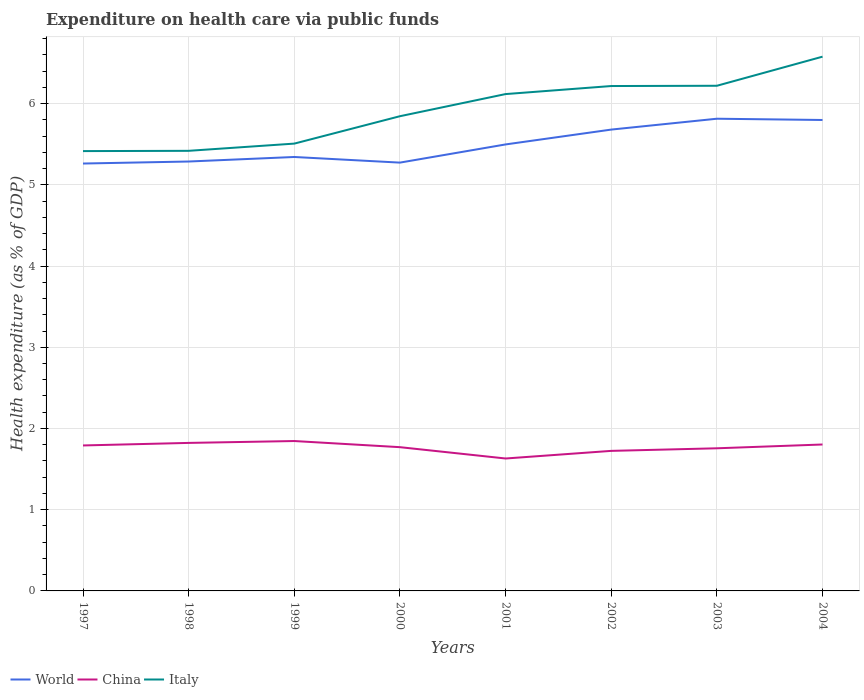How many different coloured lines are there?
Offer a very short reply. 3. Does the line corresponding to China intersect with the line corresponding to Italy?
Keep it short and to the point. No. Across all years, what is the maximum expenditure made on health care in China?
Your answer should be very brief. 1.63. In which year was the expenditure made on health care in China maximum?
Your answer should be very brief. 2001. What is the total expenditure made on health care in Italy in the graph?
Your answer should be very brief. -0.71. What is the difference between the highest and the second highest expenditure made on health care in Italy?
Provide a short and direct response. 1.16. How many lines are there?
Your response must be concise. 3. How many years are there in the graph?
Offer a very short reply. 8. What is the difference between two consecutive major ticks on the Y-axis?
Provide a short and direct response. 1. Are the values on the major ticks of Y-axis written in scientific E-notation?
Keep it short and to the point. No. Does the graph contain grids?
Your answer should be compact. Yes. How many legend labels are there?
Provide a succinct answer. 3. What is the title of the graph?
Offer a very short reply. Expenditure on health care via public funds. Does "Kiribati" appear as one of the legend labels in the graph?
Keep it short and to the point. No. What is the label or title of the Y-axis?
Make the answer very short. Health expenditure (as % of GDP). What is the Health expenditure (as % of GDP) of World in 1997?
Offer a terse response. 5.26. What is the Health expenditure (as % of GDP) of China in 1997?
Provide a short and direct response. 1.79. What is the Health expenditure (as % of GDP) of Italy in 1997?
Your answer should be compact. 5.42. What is the Health expenditure (as % of GDP) in World in 1998?
Offer a very short reply. 5.29. What is the Health expenditure (as % of GDP) of China in 1998?
Provide a short and direct response. 1.82. What is the Health expenditure (as % of GDP) of Italy in 1998?
Give a very brief answer. 5.42. What is the Health expenditure (as % of GDP) in World in 1999?
Give a very brief answer. 5.34. What is the Health expenditure (as % of GDP) in China in 1999?
Offer a terse response. 1.85. What is the Health expenditure (as % of GDP) in Italy in 1999?
Give a very brief answer. 5.51. What is the Health expenditure (as % of GDP) of World in 2000?
Your answer should be compact. 5.27. What is the Health expenditure (as % of GDP) in China in 2000?
Give a very brief answer. 1.77. What is the Health expenditure (as % of GDP) of Italy in 2000?
Provide a short and direct response. 5.84. What is the Health expenditure (as % of GDP) in World in 2001?
Make the answer very short. 5.5. What is the Health expenditure (as % of GDP) of China in 2001?
Offer a very short reply. 1.63. What is the Health expenditure (as % of GDP) in Italy in 2001?
Your answer should be compact. 6.12. What is the Health expenditure (as % of GDP) in World in 2002?
Your answer should be very brief. 5.68. What is the Health expenditure (as % of GDP) in China in 2002?
Offer a very short reply. 1.72. What is the Health expenditure (as % of GDP) in Italy in 2002?
Offer a terse response. 6.22. What is the Health expenditure (as % of GDP) of World in 2003?
Offer a terse response. 5.81. What is the Health expenditure (as % of GDP) in China in 2003?
Provide a short and direct response. 1.76. What is the Health expenditure (as % of GDP) in Italy in 2003?
Offer a terse response. 6.22. What is the Health expenditure (as % of GDP) of World in 2004?
Make the answer very short. 5.8. What is the Health expenditure (as % of GDP) of China in 2004?
Ensure brevity in your answer.  1.8. What is the Health expenditure (as % of GDP) in Italy in 2004?
Offer a very short reply. 6.58. Across all years, what is the maximum Health expenditure (as % of GDP) of World?
Your answer should be compact. 5.81. Across all years, what is the maximum Health expenditure (as % of GDP) of China?
Your answer should be very brief. 1.85. Across all years, what is the maximum Health expenditure (as % of GDP) of Italy?
Your response must be concise. 6.58. Across all years, what is the minimum Health expenditure (as % of GDP) in World?
Give a very brief answer. 5.26. Across all years, what is the minimum Health expenditure (as % of GDP) in China?
Make the answer very short. 1.63. Across all years, what is the minimum Health expenditure (as % of GDP) of Italy?
Provide a short and direct response. 5.42. What is the total Health expenditure (as % of GDP) of World in the graph?
Provide a short and direct response. 43.95. What is the total Health expenditure (as % of GDP) in China in the graph?
Provide a succinct answer. 14.14. What is the total Health expenditure (as % of GDP) in Italy in the graph?
Your response must be concise. 47.32. What is the difference between the Health expenditure (as % of GDP) of World in 1997 and that in 1998?
Offer a very short reply. -0.02. What is the difference between the Health expenditure (as % of GDP) in China in 1997 and that in 1998?
Give a very brief answer. -0.03. What is the difference between the Health expenditure (as % of GDP) of Italy in 1997 and that in 1998?
Keep it short and to the point. -0. What is the difference between the Health expenditure (as % of GDP) in World in 1997 and that in 1999?
Your response must be concise. -0.08. What is the difference between the Health expenditure (as % of GDP) in China in 1997 and that in 1999?
Offer a very short reply. -0.05. What is the difference between the Health expenditure (as % of GDP) in Italy in 1997 and that in 1999?
Your response must be concise. -0.09. What is the difference between the Health expenditure (as % of GDP) of World in 1997 and that in 2000?
Provide a succinct answer. -0.01. What is the difference between the Health expenditure (as % of GDP) in China in 1997 and that in 2000?
Ensure brevity in your answer.  0.02. What is the difference between the Health expenditure (as % of GDP) of Italy in 1997 and that in 2000?
Make the answer very short. -0.43. What is the difference between the Health expenditure (as % of GDP) in World in 1997 and that in 2001?
Offer a very short reply. -0.24. What is the difference between the Health expenditure (as % of GDP) of China in 1997 and that in 2001?
Make the answer very short. 0.16. What is the difference between the Health expenditure (as % of GDP) in Italy in 1997 and that in 2001?
Ensure brevity in your answer.  -0.7. What is the difference between the Health expenditure (as % of GDP) of World in 1997 and that in 2002?
Your response must be concise. -0.42. What is the difference between the Health expenditure (as % of GDP) of China in 1997 and that in 2002?
Provide a succinct answer. 0.07. What is the difference between the Health expenditure (as % of GDP) in Italy in 1997 and that in 2002?
Make the answer very short. -0.8. What is the difference between the Health expenditure (as % of GDP) in World in 1997 and that in 2003?
Provide a short and direct response. -0.55. What is the difference between the Health expenditure (as % of GDP) of China in 1997 and that in 2003?
Your answer should be compact. 0.03. What is the difference between the Health expenditure (as % of GDP) in Italy in 1997 and that in 2003?
Provide a short and direct response. -0.8. What is the difference between the Health expenditure (as % of GDP) in World in 1997 and that in 2004?
Your response must be concise. -0.54. What is the difference between the Health expenditure (as % of GDP) in China in 1997 and that in 2004?
Make the answer very short. -0.01. What is the difference between the Health expenditure (as % of GDP) in Italy in 1997 and that in 2004?
Keep it short and to the point. -1.16. What is the difference between the Health expenditure (as % of GDP) of World in 1998 and that in 1999?
Your response must be concise. -0.06. What is the difference between the Health expenditure (as % of GDP) of China in 1998 and that in 1999?
Offer a terse response. -0.02. What is the difference between the Health expenditure (as % of GDP) of Italy in 1998 and that in 1999?
Your response must be concise. -0.09. What is the difference between the Health expenditure (as % of GDP) in World in 1998 and that in 2000?
Keep it short and to the point. 0.01. What is the difference between the Health expenditure (as % of GDP) in China in 1998 and that in 2000?
Keep it short and to the point. 0.05. What is the difference between the Health expenditure (as % of GDP) of Italy in 1998 and that in 2000?
Provide a succinct answer. -0.43. What is the difference between the Health expenditure (as % of GDP) of World in 1998 and that in 2001?
Your answer should be very brief. -0.21. What is the difference between the Health expenditure (as % of GDP) in China in 1998 and that in 2001?
Keep it short and to the point. 0.19. What is the difference between the Health expenditure (as % of GDP) of Italy in 1998 and that in 2001?
Provide a short and direct response. -0.7. What is the difference between the Health expenditure (as % of GDP) of World in 1998 and that in 2002?
Provide a succinct answer. -0.39. What is the difference between the Health expenditure (as % of GDP) in China in 1998 and that in 2002?
Offer a very short reply. 0.1. What is the difference between the Health expenditure (as % of GDP) of Italy in 1998 and that in 2002?
Provide a short and direct response. -0.8. What is the difference between the Health expenditure (as % of GDP) in World in 1998 and that in 2003?
Give a very brief answer. -0.53. What is the difference between the Health expenditure (as % of GDP) in China in 1998 and that in 2003?
Provide a succinct answer. 0.07. What is the difference between the Health expenditure (as % of GDP) of Italy in 1998 and that in 2003?
Offer a very short reply. -0.8. What is the difference between the Health expenditure (as % of GDP) in World in 1998 and that in 2004?
Your answer should be very brief. -0.51. What is the difference between the Health expenditure (as % of GDP) of China in 1998 and that in 2004?
Make the answer very short. 0.02. What is the difference between the Health expenditure (as % of GDP) in Italy in 1998 and that in 2004?
Provide a short and direct response. -1.16. What is the difference between the Health expenditure (as % of GDP) in World in 1999 and that in 2000?
Your answer should be compact. 0.07. What is the difference between the Health expenditure (as % of GDP) of China in 1999 and that in 2000?
Make the answer very short. 0.08. What is the difference between the Health expenditure (as % of GDP) of Italy in 1999 and that in 2000?
Ensure brevity in your answer.  -0.34. What is the difference between the Health expenditure (as % of GDP) in World in 1999 and that in 2001?
Make the answer very short. -0.15. What is the difference between the Health expenditure (as % of GDP) of China in 1999 and that in 2001?
Keep it short and to the point. 0.21. What is the difference between the Health expenditure (as % of GDP) of Italy in 1999 and that in 2001?
Your response must be concise. -0.61. What is the difference between the Health expenditure (as % of GDP) in World in 1999 and that in 2002?
Your answer should be very brief. -0.34. What is the difference between the Health expenditure (as % of GDP) of China in 1999 and that in 2002?
Your answer should be compact. 0.12. What is the difference between the Health expenditure (as % of GDP) of Italy in 1999 and that in 2002?
Provide a succinct answer. -0.71. What is the difference between the Health expenditure (as % of GDP) in World in 1999 and that in 2003?
Your answer should be compact. -0.47. What is the difference between the Health expenditure (as % of GDP) in China in 1999 and that in 2003?
Your answer should be very brief. 0.09. What is the difference between the Health expenditure (as % of GDP) of Italy in 1999 and that in 2003?
Your answer should be very brief. -0.71. What is the difference between the Health expenditure (as % of GDP) in World in 1999 and that in 2004?
Provide a succinct answer. -0.46. What is the difference between the Health expenditure (as % of GDP) in China in 1999 and that in 2004?
Offer a very short reply. 0.04. What is the difference between the Health expenditure (as % of GDP) of Italy in 1999 and that in 2004?
Keep it short and to the point. -1.07. What is the difference between the Health expenditure (as % of GDP) of World in 2000 and that in 2001?
Keep it short and to the point. -0.22. What is the difference between the Health expenditure (as % of GDP) of China in 2000 and that in 2001?
Make the answer very short. 0.14. What is the difference between the Health expenditure (as % of GDP) of Italy in 2000 and that in 2001?
Ensure brevity in your answer.  -0.27. What is the difference between the Health expenditure (as % of GDP) in World in 2000 and that in 2002?
Your answer should be very brief. -0.41. What is the difference between the Health expenditure (as % of GDP) of China in 2000 and that in 2002?
Your answer should be very brief. 0.05. What is the difference between the Health expenditure (as % of GDP) in Italy in 2000 and that in 2002?
Provide a succinct answer. -0.37. What is the difference between the Health expenditure (as % of GDP) in World in 2000 and that in 2003?
Provide a short and direct response. -0.54. What is the difference between the Health expenditure (as % of GDP) of China in 2000 and that in 2003?
Offer a terse response. 0.01. What is the difference between the Health expenditure (as % of GDP) of Italy in 2000 and that in 2003?
Give a very brief answer. -0.37. What is the difference between the Health expenditure (as % of GDP) in World in 2000 and that in 2004?
Ensure brevity in your answer.  -0.53. What is the difference between the Health expenditure (as % of GDP) of China in 2000 and that in 2004?
Offer a terse response. -0.03. What is the difference between the Health expenditure (as % of GDP) in Italy in 2000 and that in 2004?
Make the answer very short. -0.73. What is the difference between the Health expenditure (as % of GDP) of World in 2001 and that in 2002?
Your answer should be compact. -0.18. What is the difference between the Health expenditure (as % of GDP) in China in 2001 and that in 2002?
Give a very brief answer. -0.09. What is the difference between the Health expenditure (as % of GDP) of Italy in 2001 and that in 2002?
Keep it short and to the point. -0.1. What is the difference between the Health expenditure (as % of GDP) of World in 2001 and that in 2003?
Provide a succinct answer. -0.32. What is the difference between the Health expenditure (as % of GDP) of China in 2001 and that in 2003?
Your response must be concise. -0.13. What is the difference between the Health expenditure (as % of GDP) of Italy in 2001 and that in 2003?
Your answer should be very brief. -0.1. What is the difference between the Health expenditure (as % of GDP) of World in 2001 and that in 2004?
Give a very brief answer. -0.3. What is the difference between the Health expenditure (as % of GDP) in China in 2001 and that in 2004?
Offer a terse response. -0.17. What is the difference between the Health expenditure (as % of GDP) in Italy in 2001 and that in 2004?
Your response must be concise. -0.46. What is the difference between the Health expenditure (as % of GDP) in World in 2002 and that in 2003?
Give a very brief answer. -0.13. What is the difference between the Health expenditure (as % of GDP) in China in 2002 and that in 2003?
Keep it short and to the point. -0.03. What is the difference between the Health expenditure (as % of GDP) in Italy in 2002 and that in 2003?
Your answer should be compact. -0. What is the difference between the Health expenditure (as % of GDP) in World in 2002 and that in 2004?
Provide a short and direct response. -0.12. What is the difference between the Health expenditure (as % of GDP) of China in 2002 and that in 2004?
Your answer should be compact. -0.08. What is the difference between the Health expenditure (as % of GDP) of Italy in 2002 and that in 2004?
Offer a terse response. -0.36. What is the difference between the Health expenditure (as % of GDP) in World in 2003 and that in 2004?
Give a very brief answer. 0.02. What is the difference between the Health expenditure (as % of GDP) in China in 2003 and that in 2004?
Offer a very short reply. -0.05. What is the difference between the Health expenditure (as % of GDP) of Italy in 2003 and that in 2004?
Give a very brief answer. -0.36. What is the difference between the Health expenditure (as % of GDP) in World in 1997 and the Health expenditure (as % of GDP) in China in 1998?
Provide a short and direct response. 3.44. What is the difference between the Health expenditure (as % of GDP) of World in 1997 and the Health expenditure (as % of GDP) of Italy in 1998?
Give a very brief answer. -0.16. What is the difference between the Health expenditure (as % of GDP) of China in 1997 and the Health expenditure (as % of GDP) of Italy in 1998?
Your response must be concise. -3.63. What is the difference between the Health expenditure (as % of GDP) of World in 1997 and the Health expenditure (as % of GDP) of China in 1999?
Make the answer very short. 3.42. What is the difference between the Health expenditure (as % of GDP) in World in 1997 and the Health expenditure (as % of GDP) in Italy in 1999?
Offer a very short reply. -0.25. What is the difference between the Health expenditure (as % of GDP) of China in 1997 and the Health expenditure (as % of GDP) of Italy in 1999?
Your response must be concise. -3.72. What is the difference between the Health expenditure (as % of GDP) of World in 1997 and the Health expenditure (as % of GDP) of China in 2000?
Your answer should be very brief. 3.49. What is the difference between the Health expenditure (as % of GDP) in World in 1997 and the Health expenditure (as % of GDP) in Italy in 2000?
Offer a very short reply. -0.58. What is the difference between the Health expenditure (as % of GDP) in China in 1997 and the Health expenditure (as % of GDP) in Italy in 2000?
Offer a very short reply. -4.05. What is the difference between the Health expenditure (as % of GDP) of World in 1997 and the Health expenditure (as % of GDP) of China in 2001?
Provide a short and direct response. 3.63. What is the difference between the Health expenditure (as % of GDP) of World in 1997 and the Health expenditure (as % of GDP) of Italy in 2001?
Ensure brevity in your answer.  -0.86. What is the difference between the Health expenditure (as % of GDP) of China in 1997 and the Health expenditure (as % of GDP) of Italy in 2001?
Your answer should be compact. -4.33. What is the difference between the Health expenditure (as % of GDP) in World in 1997 and the Health expenditure (as % of GDP) in China in 2002?
Offer a terse response. 3.54. What is the difference between the Health expenditure (as % of GDP) in World in 1997 and the Health expenditure (as % of GDP) in Italy in 2002?
Provide a succinct answer. -0.95. What is the difference between the Health expenditure (as % of GDP) of China in 1997 and the Health expenditure (as % of GDP) of Italy in 2002?
Keep it short and to the point. -4.43. What is the difference between the Health expenditure (as % of GDP) in World in 1997 and the Health expenditure (as % of GDP) in China in 2003?
Your response must be concise. 3.51. What is the difference between the Health expenditure (as % of GDP) in World in 1997 and the Health expenditure (as % of GDP) in Italy in 2003?
Offer a very short reply. -0.96. What is the difference between the Health expenditure (as % of GDP) of China in 1997 and the Health expenditure (as % of GDP) of Italy in 2003?
Provide a short and direct response. -4.43. What is the difference between the Health expenditure (as % of GDP) of World in 1997 and the Health expenditure (as % of GDP) of China in 2004?
Offer a very short reply. 3.46. What is the difference between the Health expenditure (as % of GDP) in World in 1997 and the Health expenditure (as % of GDP) in Italy in 2004?
Keep it short and to the point. -1.32. What is the difference between the Health expenditure (as % of GDP) in China in 1997 and the Health expenditure (as % of GDP) in Italy in 2004?
Offer a very short reply. -4.79. What is the difference between the Health expenditure (as % of GDP) of World in 1998 and the Health expenditure (as % of GDP) of China in 1999?
Ensure brevity in your answer.  3.44. What is the difference between the Health expenditure (as % of GDP) in World in 1998 and the Health expenditure (as % of GDP) in Italy in 1999?
Offer a terse response. -0.22. What is the difference between the Health expenditure (as % of GDP) of China in 1998 and the Health expenditure (as % of GDP) of Italy in 1999?
Provide a succinct answer. -3.68. What is the difference between the Health expenditure (as % of GDP) in World in 1998 and the Health expenditure (as % of GDP) in China in 2000?
Your answer should be compact. 3.52. What is the difference between the Health expenditure (as % of GDP) of World in 1998 and the Health expenditure (as % of GDP) of Italy in 2000?
Keep it short and to the point. -0.56. What is the difference between the Health expenditure (as % of GDP) in China in 1998 and the Health expenditure (as % of GDP) in Italy in 2000?
Ensure brevity in your answer.  -4.02. What is the difference between the Health expenditure (as % of GDP) of World in 1998 and the Health expenditure (as % of GDP) of China in 2001?
Make the answer very short. 3.66. What is the difference between the Health expenditure (as % of GDP) in World in 1998 and the Health expenditure (as % of GDP) in Italy in 2001?
Provide a succinct answer. -0.83. What is the difference between the Health expenditure (as % of GDP) of China in 1998 and the Health expenditure (as % of GDP) of Italy in 2001?
Make the answer very short. -4.29. What is the difference between the Health expenditure (as % of GDP) in World in 1998 and the Health expenditure (as % of GDP) in China in 2002?
Offer a terse response. 3.56. What is the difference between the Health expenditure (as % of GDP) in World in 1998 and the Health expenditure (as % of GDP) in Italy in 2002?
Your response must be concise. -0.93. What is the difference between the Health expenditure (as % of GDP) of China in 1998 and the Health expenditure (as % of GDP) of Italy in 2002?
Ensure brevity in your answer.  -4.39. What is the difference between the Health expenditure (as % of GDP) in World in 1998 and the Health expenditure (as % of GDP) in China in 2003?
Offer a very short reply. 3.53. What is the difference between the Health expenditure (as % of GDP) in World in 1998 and the Health expenditure (as % of GDP) in Italy in 2003?
Make the answer very short. -0.93. What is the difference between the Health expenditure (as % of GDP) of China in 1998 and the Health expenditure (as % of GDP) of Italy in 2003?
Keep it short and to the point. -4.4. What is the difference between the Health expenditure (as % of GDP) in World in 1998 and the Health expenditure (as % of GDP) in China in 2004?
Provide a short and direct response. 3.48. What is the difference between the Health expenditure (as % of GDP) of World in 1998 and the Health expenditure (as % of GDP) of Italy in 2004?
Make the answer very short. -1.29. What is the difference between the Health expenditure (as % of GDP) of China in 1998 and the Health expenditure (as % of GDP) of Italy in 2004?
Your answer should be compact. -4.76. What is the difference between the Health expenditure (as % of GDP) in World in 1999 and the Health expenditure (as % of GDP) in China in 2000?
Your answer should be very brief. 3.57. What is the difference between the Health expenditure (as % of GDP) of World in 1999 and the Health expenditure (as % of GDP) of Italy in 2000?
Offer a very short reply. -0.5. What is the difference between the Health expenditure (as % of GDP) of China in 1999 and the Health expenditure (as % of GDP) of Italy in 2000?
Make the answer very short. -4. What is the difference between the Health expenditure (as % of GDP) in World in 1999 and the Health expenditure (as % of GDP) in China in 2001?
Give a very brief answer. 3.71. What is the difference between the Health expenditure (as % of GDP) of World in 1999 and the Health expenditure (as % of GDP) of Italy in 2001?
Provide a succinct answer. -0.77. What is the difference between the Health expenditure (as % of GDP) in China in 1999 and the Health expenditure (as % of GDP) in Italy in 2001?
Make the answer very short. -4.27. What is the difference between the Health expenditure (as % of GDP) of World in 1999 and the Health expenditure (as % of GDP) of China in 2002?
Offer a very short reply. 3.62. What is the difference between the Health expenditure (as % of GDP) of World in 1999 and the Health expenditure (as % of GDP) of Italy in 2002?
Ensure brevity in your answer.  -0.87. What is the difference between the Health expenditure (as % of GDP) of China in 1999 and the Health expenditure (as % of GDP) of Italy in 2002?
Provide a succinct answer. -4.37. What is the difference between the Health expenditure (as % of GDP) in World in 1999 and the Health expenditure (as % of GDP) in China in 2003?
Your answer should be very brief. 3.59. What is the difference between the Health expenditure (as % of GDP) in World in 1999 and the Health expenditure (as % of GDP) in Italy in 2003?
Keep it short and to the point. -0.88. What is the difference between the Health expenditure (as % of GDP) of China in 1999 and the Health expenditure (as % of GDP) of Italy in 2003?
Provide a short and direct response. -4.37. What is the difference between the Health expenditure (as % of GDP) of World in 1999 and the Health expenditure (as % of GDP) of China in 2004?
Provide a short and direct response. 3.54. What is the difference between the Health expenditure (as % of GDP) in World in 1999 and the Health expenditure (as % of GDP) in Italy in 2004?
Provide a succinct answer. -1.24. What is the difference between the Health expenditure (as % of GDP) in China in 1999 and the Health expenditure (as % of GDP) in Italy in 2004?
Make the answer very short. -4.73. What is the difference between the Health expenditure (as % of GDP) of World in 2000 and the Health expenditure (as % of GDP) of China in 2001?
Your response must be concise. 3.64. What is the difference between the Health expenditure (as % of GDP) of World in 2000 and the Health expenditure (as % of GDP) of Italy in 2001?
Offer a terse response. -0.84. What is the difference between the Health expenditure (as % of GDP) of China in 2000 and the Health expenditure (as % of GDP) of Italy in 2001?
Give a very brief answer. -4.35. What is the difference between the Health expenditure (as % of GDP) of World in 2000 and the Health expenditure (as % of GDP) of China in 2002?
Your response must be concise. 3.55. What is the difference between the Health expenditure (as % of GDP) of World in 2000 and the Health expenditure (as % of GDP) of Italy in 2002?
Keep it short and to the point. -0.94. What is the difference between the Health expenditure (as % of GDP) in China in 2000 and the Health expenditure (as % of GDP) in Italy in 2002?
Offer a very short reply. -4.45. What is the difference between the Health expenditure (as % of GDP) in World in 2000 and the Health expenditure (as % of GDP) in China in 2003?
Ensure brevity in your answer.  3.52. What is the difference between the Health expenditure (as % of GDP) of World in 2000 and the Health expenditure (as % of GDP) of Italy in 2003?
Offer a terse response. -0.95. What is the difference between the Health expenditure (as % of GDP) in China in 2000 and the Health expenditure (as % of GDP) in Italy in 2003?
Your answer should be compact. -4.45. What is the difference between the Health expenditure (as % of GDP) of World in 2000 and the Health expenditure (as % of GDP) of China in 2004?
Your answer should be compact. 3.47. What is the difference between the Health expenditure (as % of GDP) in World in 2000 and the Health expenditure (as % of GDP) in Italy in 2004?
Your answer should be compact. -1.3. What is the difference between the Health expenditure (as % of GDP) of China in 2000 and the Health expenditure (as % of GDP) of Italy in 2004?
Your answer should be very brief. -4.81. What is the difference between the Health expenditure (as % of GDP) in World in 2001 and the Health expenditure (as % of GDP) in China in 2002?
Your answer should be very brief. 3.77. What is the difference between the Health expenditure (as % of GDP) in World in 2001 and the Health expenditure (as % of GDP) in Italy in 2002?
Provide a succinct answer. -0.72. What is the difference between the Health expenditure (as % of GDP) in China in 2001 and the Health expenditure (as % of GDP) in Italy in 2002?
Offer a terse response. -4.59. What is the difference between the Health expenditure (as % of GDP) in World in 2001 and the Health expenditure (as % of GDP) in China in 2003?
Keep it short and to the point. 3.74. What is the difference between the Health expenditure (as % of GDP) in World in 2001 and the Health expenditure (as % of GDP) in Italy in 2003?
Provide a short and direct response. -0.72. What is the difference between the Health expenditure (as % of GDP) of China in 2001 and the Health expenditure (as % of GDP) of Italy in 2003?
Your answer should be compact. -4.59. What is the difference between the Health expenditure (as % of GDP) of World in 2001 and the Health expenditure (as % of GDP) of China in 2004?
Provide a short and direct response. 3.69. What is the difference between the Health expenditure (as % of GDP) in World in 2001 and the Health expenditure (as % of GDP) in Italy in 2004?
Make the answer very short. -1.08. What is the difference between the Health expenditure (as % of GDP) of China in 2001 and the Health expenditure (as % of GDP) of Italy in 2004?
Keep it short and to the point. -4.95. What is the difference between the Health expenditure (as % of GDP) in World in 2002 and the Health expenditure (as % of GDP) in China in 2003?
Provide a short and direct response. 3.92. What is the difference between the Health expenditure (as % of GDP) in World in 2002 and the Health expenditure (as % of GDP) in Italy in 2003?
Keep it short and to the point. -0.54. What is the difference between the Health expenditure (as % of GDP) in China in 2002 and the Health expenditure (as % of GDP) in Italy in 2003?
Offer a terse response. -4.5. What is the difference between the Health expenditure (as % of GDP) in World in 2002 and the Health expenditure (as % of GDP) in China in 2004?
Keep it short and to the point. 3.88. What is the difference between the Health expenditure (as % of GDP) of World in 2002 and the Health expenditure (as % of GDP) of Italy in 2004?
Your response must be concise. -0.9. What is the difference between the Health expenditure (as % of GDP) in China in 2002 and the Health expenditure (as % of GDP) in Italy in 2004?
Make the answer very short. -4.85. What is the difference between the Health expenditure (as % of GDP) in World in 2003 and the Health expenditure (as % of GDP) in China in 2004?
Your answer should be very brief. 4.01. What is the difference between the Health expenditure (as % of GDP) in World in 2003 and the Health expenditure (as % of GDP) in Italy in 2004?
Provide a succinct answer. -0.76. What is the difference between the Health expenditure (as % of GDP) of China in 2003 and the Health expenditure (as % of GDP) of Italy in 2004?
Make the answer very short. -4.82. What is the average Health expenditure (as % of GDP) of World per year?
Give a very brief answer. 5.49. What is the average Health expenditure (as % of GDP) in China per year?
Offer a terse response. 1.77. What is the average Health expenditure (as % of GDP) in Italy per year?
Your answer should be compact. 5.91. In the year 1997, what is the difference between the Health expenditure (as % of GDP) of World and Health expenditure (as % of GDP) of China?
Your response must be concise. 3.47. In the year 1997, what is the difference between the Health expenditure (as % of GDP) in World and Health expenditure (as % of GDP) in Italy?
Keep it short and to the point. -0.15. In the year 1997, what is the difference between the Health expenditure (as % of GDP) of China and Health expenditure (as % of GDP) of Italy?
Give a very brief answer. -3.62. In the year 1998, what is the difference between the Health expenditure (as % of GDP) in World and Health expenditure (as % of GDP) in China?
Give a very brief answer. 3.46. In the year 1998, what is the difference between the Health expenditure (as % of GDP) of World and Health expenditure (as % of GDP) of Italy?
Ensure brevity in your answer.  -0.13. In the year 1998, what is the difference between the Health expenditure (as % of GDP) of China and Health expenditure (as % of GDP) of Italy?
Your answer should be very brief. -3.6. In the year 1999, what is the difference between the Health expenditure (as % of GDP) of World and Health expenditure (as % of GDP) of China?
Provide a succinct answer. 3.5. In the year 1999, what is the difference between the Health expenditure (as % of GDP) in World and Health expenditure (as % of GDP) in Italy?
Provide a short and direct response. -0.16. In the year 1999, what is the difference between the Health expenditure (as % of GDP) in China and Health expenditure (as % of GDP) in Italy?
Your answer should be compact. -3.66. In the year 2000, what is the difference between the Health expenditure (as % of GDP) in World and Health expenditure (as % of GDP) in China?
Your answer should be compact. 3.5. In the year 2000, what is the difference between the Health expenditure (as % of GDP) in World and Health expenditure (as % of GDP) in Italy?
Give a very brief answer. -0.57. In the year 2000, what is the difference between the Health expenditure (as % of GDP) of China and Health expenditure (as % of GDP) of Italy?
Your response must be concise. -4.07. In the year 2001, what is the difference between the Health expenditure (as % of GDP) of World and Health expenditure (as % of GDP) of China?
Make the answer very short. 3.87. In the year 2001, what is the difference between the Health expenditure (as % of GDP) of World and Health expenditure (as % of GDP) of Italy?
Keep it short and to the point. -0.62. In the year 2001, what is the difference between the Health expenditure (as % of GDP) in China and Health expenditure (as % of GDP) in Italy?
Offer a terse response. -4.49. In the year 2002, what is the difference between the Health expenditure (as % of GDP) in World and Health expenditure (as % of GDP) in China?
Provide a short and direct response. 3.96. In the year 2002, what is the difference between the Health expenditure (as % of GDP) in World and Health expenditure (as % of GDP) in Italy?
Give a very brief answer. -0.54. In the year 2002, what is the difference between the Health expenditure (as % of GDP) in China and Health expenditure (as % of GDP) in Italy?
Provide a short and direct response. -4.49. In the year 2003, what is the difference between the Health expenditure (as % of GDP) of World and Health expenditure (as % of GDP) of China?
Ensure brevity in your answer.  4.06. In the year 2003, what is the difference between the Health expenditure (as % of GDP) of World and Health expenditure (as % of GDP) of Italy?
Make the answer very short. -0.41. In the year 2003, what is the difference between the Health expenditure (as % of GDP) in China and Health expenditure (as % of GDP) in Italy?
Your response must be concise. -4.46. In the year 2004, what is the difference between the Health expenditure (as % of GDP) in World and Health expenditure (as % of GDP) in China?
Offer a terse response. 4. In the year 2004, what is the difference between the Health expenditure (as % of GDP) in World and Health expenditure (as % of GDP) in Italy?
Give a very brief answer. -0.78. In the year 2004, what is the difference between the Health expenditure (as % of GDP) in China and Health expenditure (as % of GDP) in Italy?
Your answer should be compact. -4.77. What is the ratio of the Health expenditure (as % of GDP) of China in 1997 to that in 1998?
Provide a succinct answer. 0.98. What is the ratio of the Health expenditure (as % of GDP) in World in 1997 to that in 1999?
Ensure brevity in your answer.  0.98. What is the ratio of the Health expenditure (as % of GDP) in China in 1997 to that in 1999?
Offer a very short reply. 0.97. What is the ratio of the Health expenditure (as % of GDP) of Italy in 1997 to that in 1999?
Keep it short and to the point. 0.98. What is the ratio of the Health expenditure (as % of GDP) of China in 1997 to that in 2000?
Your response must be concise. 1.01. What is the ratio of the Health expenditure (as % of GDP) of Italy in 1997 to that in 2000?
Provide a short and direct response. 0.93. What is the ratio of the Health expenditure (as % of GDP) of World in 1997 to that in 2001?
Your answer should be very brief. 0.96. What is the ratio of the Health expenditure (as % of GDP) in China in 1997 to that in 2001?
Provide a succinct answer. 1.1. What is the ratio of the Health expenditure (as % of GDP) of Italy in 1997 to that in 2001?
Keep it short and to the point. 0.89. What is the ratio of the Health expenditure (as % of GDP) of World in 1997 to that in 2002?
Provide a succinct answer. 0.93. What is the ratio of the Health expenditure (as % of GDP) in China in 1997 to that in 2002?
Make the answer very short. 1.04. What is the ratio of the Health expenditure (as % of GDP) of Italy in 1997 to that in 2002?
Ensure brevity in your answer.  0.87. What is the ratio of the Health expenditure (as % of GDP) in World in 1997 to that in 2003?
Provide a succinct answer. 0.91. What is the ratio of the Health expenditure (as % of GDP) in China in 1997 to that in 2003?
Your answer should be very brief. 1.02. What is the ratio of the Health expenditure (as % of GDP) in Italy in 1997 to that in 2003?
Offer a terse response. 0.87. What is the ratio of the Health expenditure (as % of GDP) in World in 1997 to that in 2004?
Your answer should be compact. 0.91. What is the ratio of the Health expenditure (as % of GDP) of Italy in 1997 to that in 2004?
Your answer should be compact. 0.82. What is the ratio of the Health expenditure (as % of GDP) in World in 1998 to that in 1999?
Keep it short and to the point. 0.99. What is the ratio of the Health expenditure (as % of GDP) of China in 1998 to that in 1999?
Ensure brevity in your answer.  0.99. What is the ratio of the Health expenditure (as % of GDP) of Italy in 1998 to that in 1999?
Your answer should be very brief. 0.98. What is the ratio of the Health expenditure (as % of GDP) of World in 1998 to that in 2000?
Offer a terse response. 1. What is the ratio of the Health expenditure (as % of GDP) of China in 1998 to that in 2000?
Your answer should be very brief. 1.03. What is the ratio of the Health expenditure (as % of GDP) of Italy in 1998 to that in 2000?
Your answer should be very brief. 0.93. What is the ratio of the Health expenditure (as % of GDP) of World in 1998 to that in 2001?
Your answer should be compact. 0.96. What is the ratio of the Health expenditure (as % of GDP) of China in 1998 to that in 2001?
Make the answer very short. 1.12. What is the ratio of the Health expenditure (as % of GDP) of Italy in 1998 to that in 2001?
Provide a short and direct response. 0.89. What is the ratio of the Health expenditure (as % of GDP) in World in 1998 to that in 2002?
Provide a short and direct response. 0.93. What is the ratio of the Health expenditure (as % of GDP) in China in 1998 to that in 2002?
Your answer should be compact. 1.06. What is the ratio of the Health expenditure (as % of GDP) in Italy in 1998 to that in 2002?
Offer a terse response. 0.87. What is the ratio of the Health expenditure (as % of GDP) of World in 1998 to that in 2003?
Your answer should be compact. 0.91. What is the ratio of the Health expenditure (as % of GDP) in China in 1998 to that in 2003?
Keep it short and to the point. 1.04. What is the ratio of the Health expenditure (as % of GDP) in Italy in 1998 to that in 2003?
Your response must be concise. 0.87. What is the ratio of the Health expenditure (as % of GDP) in World in 1998 to that in 2004?
Provide a succinct answer. 0.91. What is the ratio of the Health expenditure (as % of GDP) in China in 1998 to that in 2004?
Your response must be concise. 1.01. What is the ratio of the Health expenditure (as % of GDP) of Italy in 1998 to that in 2004?
Give a very brief answer. 0.82. What is the ratio of the Health expenditure (as % of GDP) of World in 1999 to that in 2000?
Your answer should be very brief. 1.01. What is the ratio of the Health expenditure (as % of GDP) of China in 1999 to that in 2000?
Ensure brevity in your answer.  1.04. What is the ratio of the Health expenditure (as % of GDP) of Italy in 1999 to that in 2000?
Ensure brevity in your answer.  0.94. What is the ratio of the Health expenditure (as % of GDP) in World in 1999 to that in 2001?
Keep it short and to the point. 0.97. What is the ratio of the Health expenditure (as % of GDP) of China in 1999 to that in 2001?
Offer a terse response. 1.13. What is the ratio of the Health expenditure (as % of GDP) in Italy in 1999 to that in 2001?
Give a very brief answer. 0.9. What is the ratio of the Health expenditure (as % of GDP) in World in 1999 to that in 2002?
Offer a very short reply. 0.94. What is the ratio of the Health expenditure (as % of GDP) in China in 1999 to that in 2002?
Provide a succinct answer. 1.07. What is the ratio of the Health expenditure (as % of GDP) of Italy in 1999 to that in 2002?
Provide a succinct answer. 0.89. What is the ratio of the Health expenditure (as % of GDP) in World in 1999 to that in 2003?
Keep it short and to the point. 0.92. What is the ratio of the Health expenditure (as % of GDP) of China in 1999 to that in 2003?
Give a very brief answer. 1.05. What is the ratio of the Health expenditure (as % of GDP) of Italy in 1999 to that in 2003?
Provide a short and direct response. 0.89. What is the ratio of the Health expenditure (as % of GDP) of World in 1999 to that in 2004?
Offer a terse response. 0.92. What is the ratio of the Health expenditure (as % of GDP) of China in 1999 to that in 2004?
Ensure brevity in your answer.  1.02. What is the ratio of the Health expenditure (as % of GDP) of Italy in 1999 to that in 2004?
Your response must be concise. 0.84. What is the ratio of the Health expenditure (as % of GDP) in World in 2000 to that in 2001?
Ensure brevity in your answer.  0.96. What is the ratio of the Health expenditure (as % of GDP) of China in 2000 to that in 2001?
Ensure brevity in your answer.  1.09. What is the ratio of the Health expenditure (as % of GDP) in Italy in 2000 to that in 2001?
Your response must be concise. 0.96. What is the ratio of the Health expenditure (as % of GDP) of World in 2000 to that in 2002?
Ensure brevity in your answer.  0.93. What is the ratio of the Health expenditure (as % of GDP) in China in 2000 to that in 2002?
Ensure brevity in your answer.  1.03. What is the ratio of the Health expenditure (as % of GDP) of Italy in 2000 to that in 2002?
Offer a very short reply. 0.94. What is the ratio of the Health expenditure (as % of GDP) of World in 2000 to that in 2003?
Ensure brevity in your answer.  0.91. What is the ratio of the Health expenditure (as % of GDP) in China in 2000 to that in 2003?
Give a very brief answer. 1.01. What is the ratio of the Health expenditure (as % of GDP) of Italy in 2000 to that in 2003?
Provide a succinct answer. 0.94. What is the ratio of the Health expenditure (as % of GDP) of World in 2000 to that in 2004?
Your answer should be very brief. 0.91. What is the ratio of the Health expenditure (as % of GDP) in China in 2000 to that in 2004?
Ensure brevity in your answer.  0.98. What is the ratio of the Health expenditure (as % of GDP) in Italy in 2000 to that in 2004?
Keep it short and to the point. 0.89. What is the ratio of the Health expenditure (as % of GDP) in World in 2001 to that in 2002?
Give a very brief answer. 0.97. What is the ratio of the Health expenditure (as % of GDP) of China in 2001 to that in 2002?
Your response must be concise. 0.95. What is the ratio of the Health expenditure (as % of GDP) in Italy in 2001 to that in 2002?
Your answer should be very brief. 0.98. What is the ratio of the Health expenditure (as % of GDP) in World in 2001 to that in 2003?
Provide a short and direct response. 0.95. What is the ratio of the Health expenditure (as % of GDP) in China in 2001 to that in 2003?
Provide a short and direct response. 0.93. What is the ratio of the Health expenditure (as % of GDP) in Italy in 2001 to that in 2003?
Provide a short and direct response. 0.98. What is the ratio of the Health expenditure (as % of GDP) in World in 2001 to that in 2004?
Offer a very short reply. 0.95. What is the ratio of the Health expenditure (as % of GDP) of China in 2001 to that in 2004?
Provide a short and direct response. 0.9. What is the ratio of the Health expenditure (as % of GDP) of China in 2002 to that in 2003?
Your answer should be compact. 0.98. What is the ratio of the Health expenditure (as % of GDP) in World in 2002 to that in 2004?
Offer a terse response. 0.98. What is the ratio of the Health expenditure (as % of GDP) in China in 2002 to that in 2004?
Ensure brevity in your answer.  0.96. What is the ratio of the Health expenditure (as % of GDP) in Italy in 2002 to that in 2004?
Make the answer very short. 0.94. What is the ratio of the Health expenditure (as % of GDP) of World in 2003 to that in 2004?
Offer a terse response. 1. What is the ratio of the Health expenditure (as % of GDP) in China in 2003 to that in 2004?
Give a very brief answer. 0.97. What is the ratio of the Health expenditure (as % of GDP) of Italy in 2003 to that in 2004?
Provide a short and direct response. 0.95. What is the difference between the highest and the second highest Health expenditure (as % of GDP) of World?
Your answer should be very brief. 0.02. What is the difference between the highest and the second highest Health expenditure (as % of GDP) in China?
Ensure brevity in your answer.  0.02. What is the difference between the highest and the second highest Health expenditure (as % of GDP) in Italy?
Make the answer very short. 0.36. What is the difference between the highest and the lowest Health expenditure (as % of GDP) in World?
Your response must be concise. 0.55. What is the difference between the highest and the lowest Health expenditure (as % of GDP) of China?
Ensure brevity in your answer.  0.21. What is the difference between the highest and the lowest Health expenditure (as % of GDP) of Italy?
Provide a short and direct response. 1.16. 